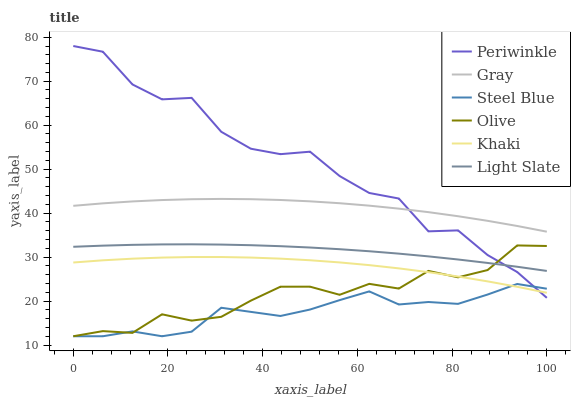Does Steel Blue have the minimum area under the curve?
Answer yes or no. Yes. Does Periwinkle have the maximum area under the curve?
Answer yes or no. Yes. Does Khaki have the minimum area under the curve?
Answer yes or no. No. Does Khaki have the maximum area under the curve?
Answer yes or no. No. Is Light Slate the smoothest?
Answer yes or no. Yes. Is Periwinkle the roughest?
Answer yes or no. Yes. Is Khaki the smoothest?
Answer yes or no. No. Is Khaki the roughest?
Answer yes or no. No. Does Steel Blue have the lowest value?
Answer yes or no. Yes. Does Khaki have the lowest value?
Answer yes or no. No. Does Periwinkle have the highest value?
Answer yes or no. Yes. Does Khaki have the highest value?
Answer yes or no. No. Is Steel Blue less than Light Slate?
Answer yes or no. Yes. Is Light Slate greater than Steel Blue?
Answer yes or no. Yes. Does Light Slate intersect Olive?
Answer yes or no. Yes. Is Light Slate less than Olive?
Answer yes or no. No. Is Light Slate greater than Olive?
Answer yes or no. No. Does Steel Blue intersect Light Slate?
Answer yes or no. No. 